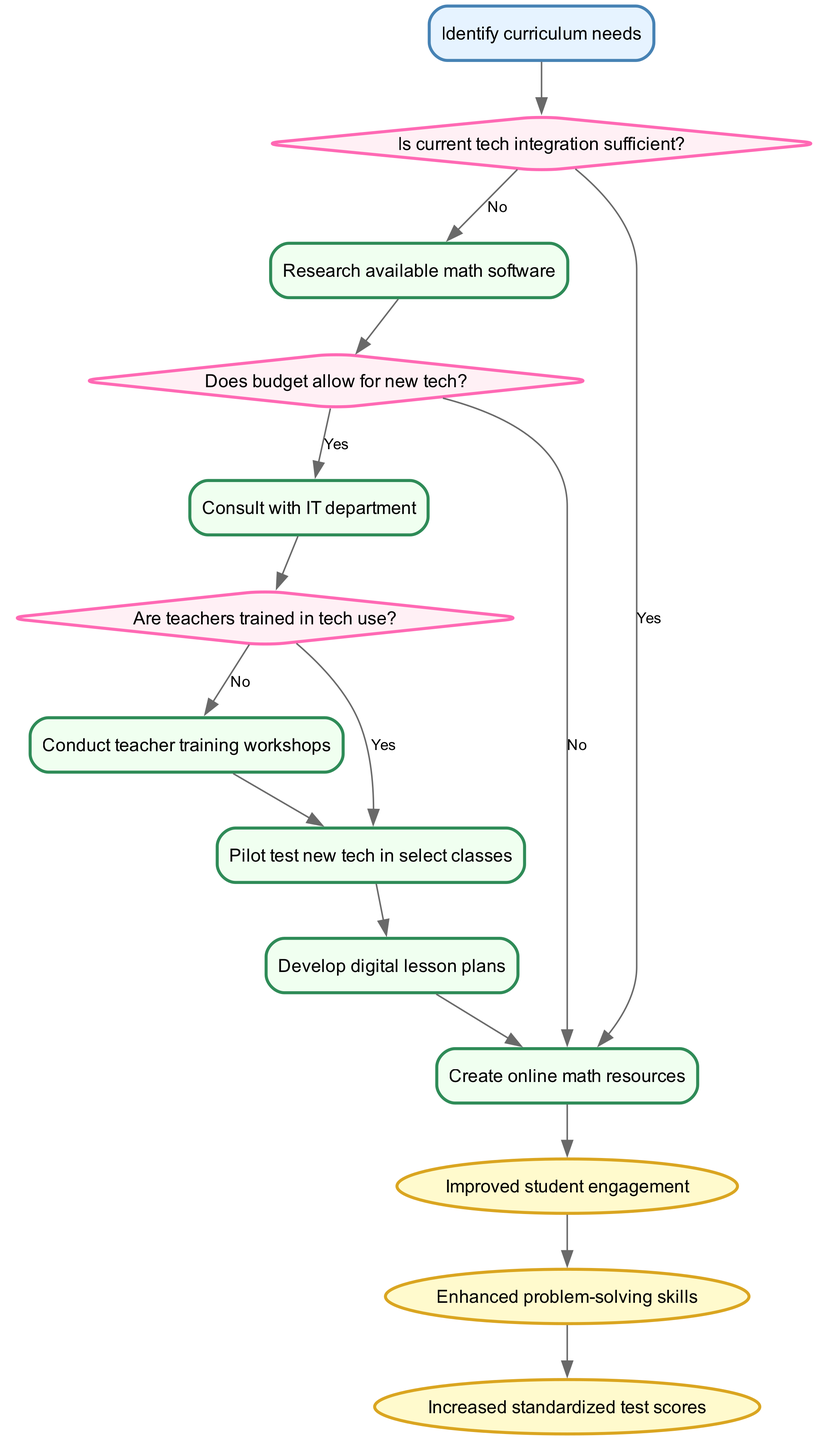What is the starting point of the pathway? The starting point is labeled as "Identify curriculum needs" in the diagram, which is the first action to take in the clinical pathway.
Answer: Identify curriculum needs How many decision points are there in the diagram? By reviewing the diagram, we can count a total of three decision points: "Is current tech integration sufficient?", "Does budget allow for new tech?", and "Are teachers trained in tech use?"
Answer: 3 What action follows the decision point "Does budget allow for new tech?" if the answer is yes? Following the decision point "Does budget allow for new tech?", the action that follows is "Consult with IT department" when the answer is yes.
Answer: Consult with IT department Which outcome is connected to "Create online math resources"? The outcome directly connected to "Create online math resources" in the diagram is "Improved student engagement." This shows a flow from the action to the expected result.
Answer: Improved student engagement What action must be performed if teachers are not trained in tech use? If teachers are not trained in tech use, the action to be performed is "Conduct teacher training workshops" as indicated in the flow of the diagram.
Answer: Conduct teacher training workshops What is the last outcome in the pathway? The last outcome in the pathway, following the flow from "Enhanced problem-solving skills," is "Increased standardized test scores." This sets the final result of the pathway's efforts.
Answer: Increased standardized test scores What is the relationship between "Pilot test new tech in select classes" and "Develop digital lesson plans"? The relationship indicates that "Pilot test new tech in select classes" leads to the next action of "Develop digital lesson plans", showing a sequential flow from testing to planning.
Answer: Develop digital lesson plans If the answer is no to "Is current tech integration sufficient?", what action is taken next? If the answer to "Is current tech integration sufficient?" is no, the next action to take is "Research available math software" as shown in the diagram.
Answer: Research available math software What is the final node in the clinical pathway? The final node in the clinical pathway is "Increased standardized test scores," indicating the ultimate goal of integrating technology into the curriculum.
Answer: Increased standardized test scores 